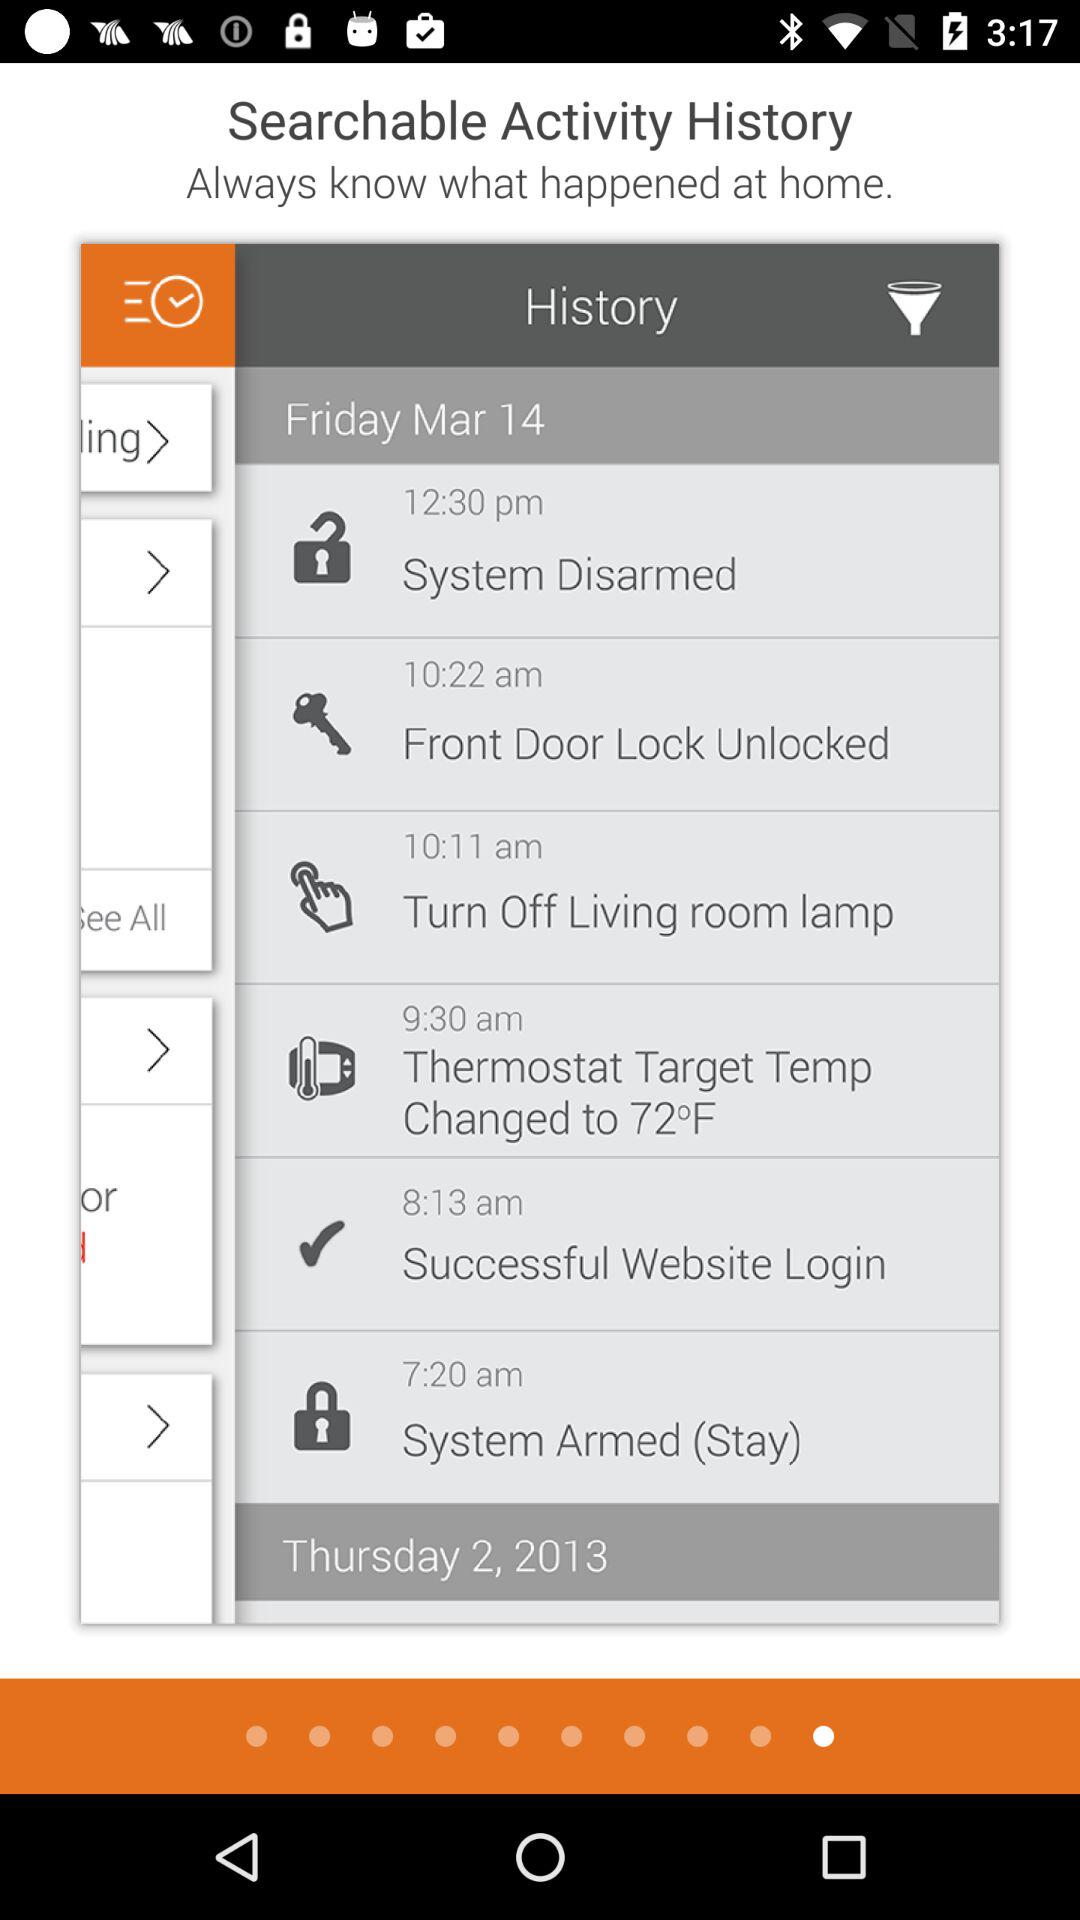What is the time of the "Front Door Lock Unlocked"? The time is 10:22 a.m. 